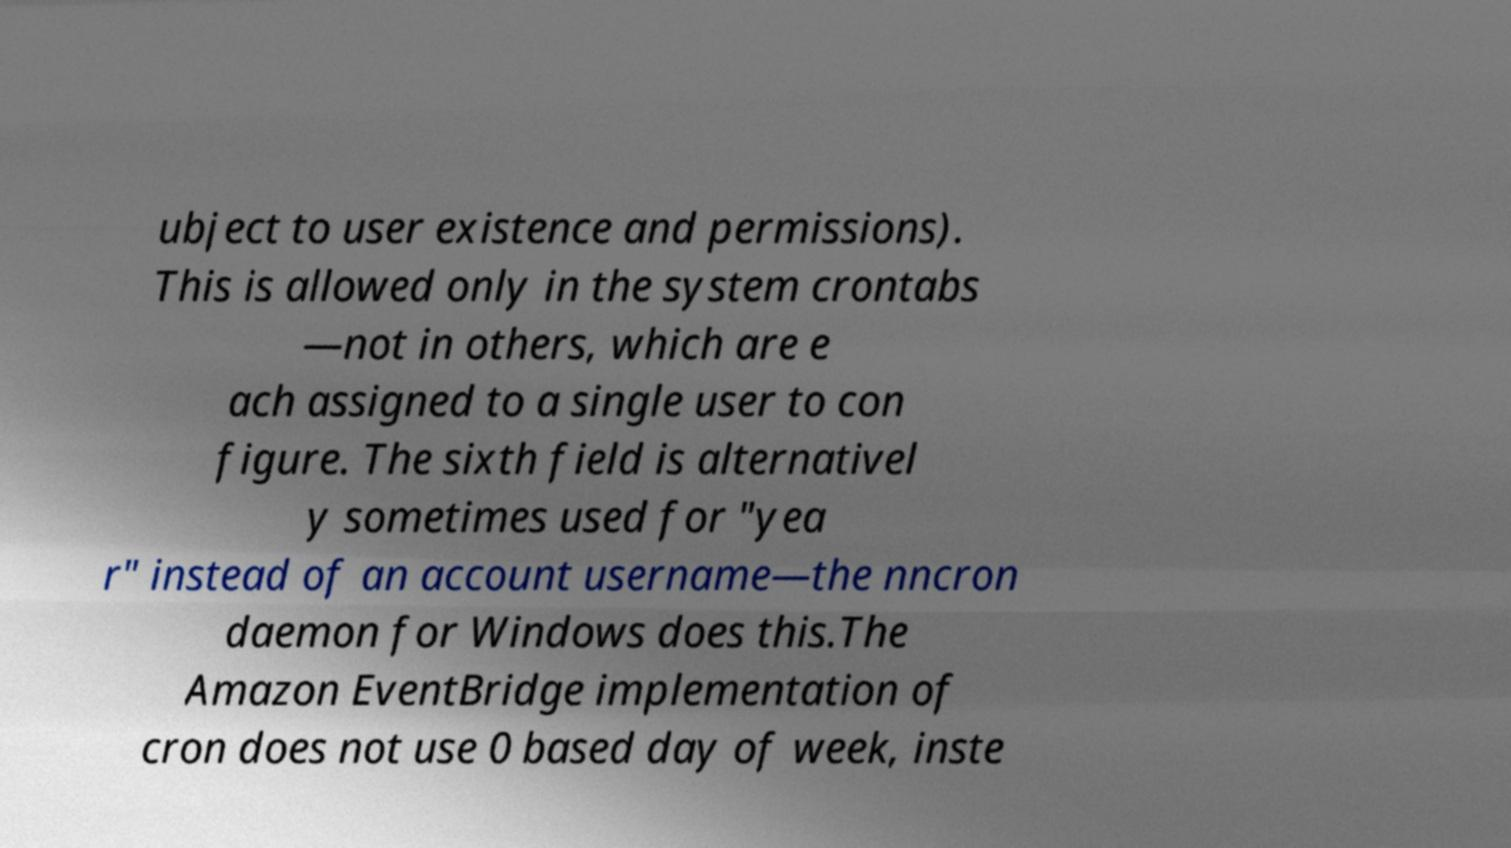Please identify and transcribe the text found in this image. ubject to user existence and permissions). This is allowed only in the system crontabs —not in others, which are e ach assigned to a single user to con figure. The sixth field is alternativel y sometimes used for "yea r" instead of an account username—the nncron daemon for Windows does this.The Amazon EventBridge implementation of cron does not use 0 based day of week, inste 